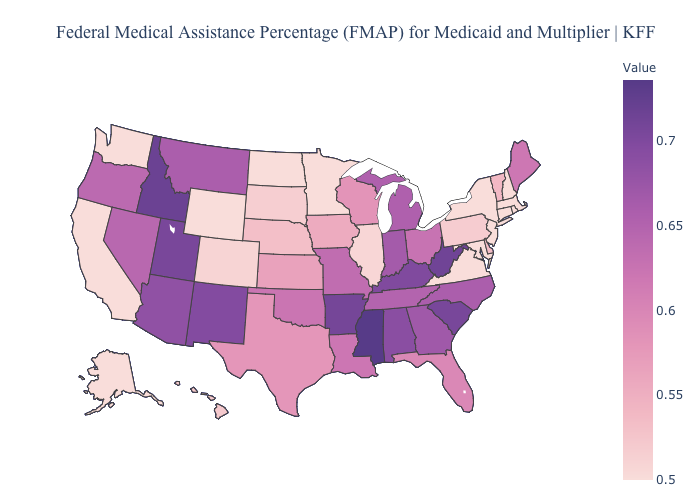Which states hav the highest value in the Northeast?
Give a very brief answer. Maine. Among the states that border North Carolina , does South Carolina have the highest value?
Be succinct. Yes. Does Alaska have the lowest value in the USA?
Give a very brief answer. Yes. Does Utah have a lower value than Mississippi?
Keep it brief. Yes. 